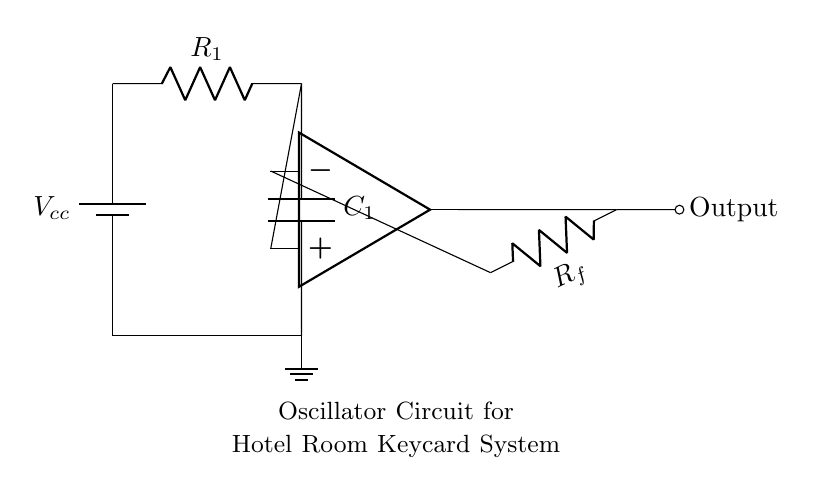What type of circuit is shown? The circuit is an oscillator, indicated by the presence of an RC network and a feedback loop involving an operational amplifier. These features are characteristic of oscillator circuits, which generate periodic signals.
Answer: Oscillator What is the function of the capacitor in this circuit? The capacitor in the RC network is used to store and release charge, which helps in determining the oscillation frequency along with the resistor. Its charging and discharging action create a timing element essential for generating oscillations.
Answer: Timing element What component provides feedback in the circuit? The feedback in the circuit is provided by the resistor labeled R_f, which connects the output of the op-amp back to its inverting input, thus establishing the necessary feedback for oscillation.
Answer: Resistor R_f What is the label of the power supply? The power supply is labeled V_cc, indicating the voltage source that powers the oscillator circuit and is necessary for the operation of all components including the op-amp.
Answer: V_cc How does the frequency of the oscillations relate to R_1 and C_1? The frequency of the oscillations is inversely related to the product of resistance R_1 and capacitance C_1. This is formulated in the oscillator frequency equation, showing that changes in R_1 or C_1 will affect the oscillation frequency proportionately.
Answer: Inversely related 